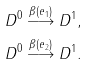Convert formula to latex. <formula><loc_0><loc_0><loc_500><loc_500>& D ^ { 0 } \overset { \beta ( e _ { 1 } ) } { \longrightarrow } D ^ { 1 } , \\ & D ^ { 0 } \overset { \beta ( e _ { 2 } ) } { \longrightarrow } D ^ { 1 } .</formula> 